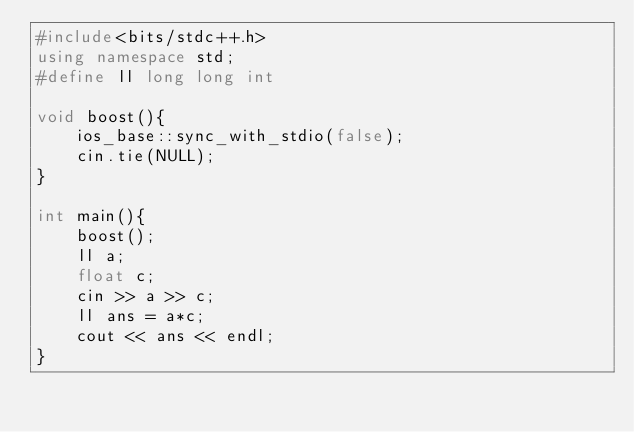Convert code to text. <code><loc_0><loc_0><loc_500><loc_500><_C++_>#include<bits/stdc++.h>
using namespace std;
#define ll long long int

void boost(){
    ios_base::sync_with_stdio(false);
    cin.tie(NULL);
}

int main(){
    boost();
    ll a;
    float c;
    cin >> a >> c;
    ll ans = a*c;
    cout << ans << endl;
}</code> 